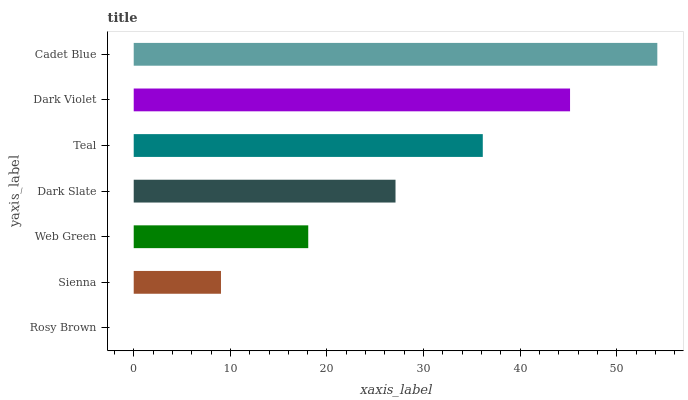Is Rosy Brown the minimum?
Answer yes or no. Yes. Is Cadet Blue the maximum?
Answer yes or no. Yes. Is Sienna the minimum?
Answer yes or no. No. Is Sienna the maximum?
Answer yes or no. No. Is Sienna greater than Rosy Brown?
Answer yes or no. Yes. Is Rosy Brown less than Sienna?
Answer yes or no. Yes. Is Rosy Brown greater than Sienna?
Answer yes or no. No. Is Sienna less than Rosy Brown?
Answer yes or no. No. Is Dark Slate the high median?
Answer yes or no. Yes. Is Dark Slate the low median?
Answer yes or no. Yes. Is Rosy Brown the high median?
Answer yes or no. No. Is Teal the low median?
Answer yes or no. No. 